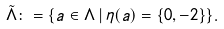Convert formula to latex. <formula><loc_0><loc_0><loc_500><loc_500>\tilde { \Lambda } \colon = \{ a \in \Lambda \, | \, \eta ( a ) = \{ 0 , - 2 \} \} .</formula> 